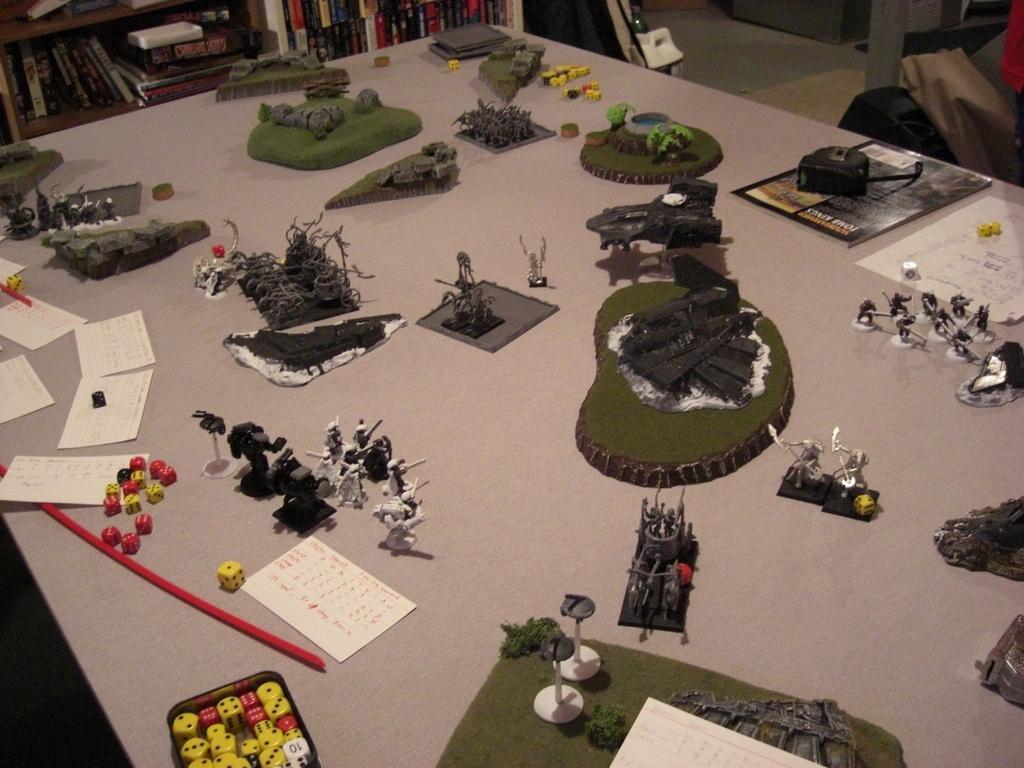Please provide a concise description of this image. There are few objects placed on a table and there is a book shelf in the background. 